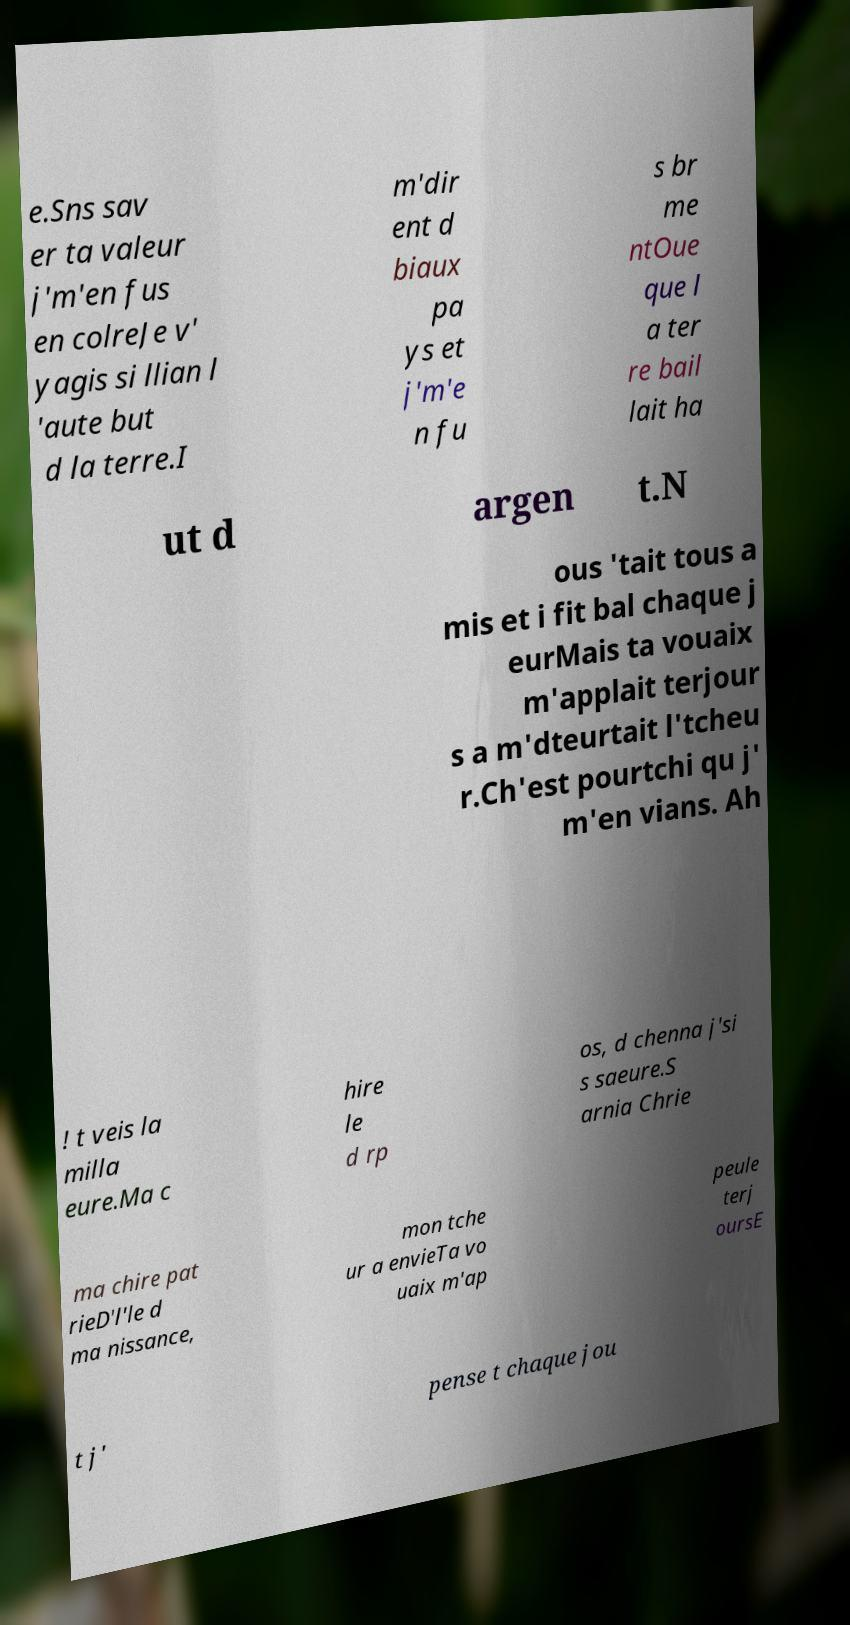Can you read and provide the text displayed in the image?This photo seems to have some interesting text. Can you extract and type it out for me? e.Sns sav er ta valeur j'm'en fus en colreJe v' yagis si llian l 'aute but d la terre.I m'dir ent d biaux pa ys et j'm'e n fu s br me ntOue que l a ter re bail lait ha ut d argen t.N ous 'tait tous a mis et i fit bal chaque j eurMais ta vouaix m'applait terjour s a m'dteurtait l'tcheu r.Ch'est pourtchi qu j' m'en vians. Ah ! t veis la milla eure.Ma c hire le d rp os, d chenna j'si s saeure.S arnia Chrie ma chire pat rieD'l'le d ma nissance, mon tche ur a envieTa vo uaix m'ap peule terj oursE t j' pense t chaque jou 